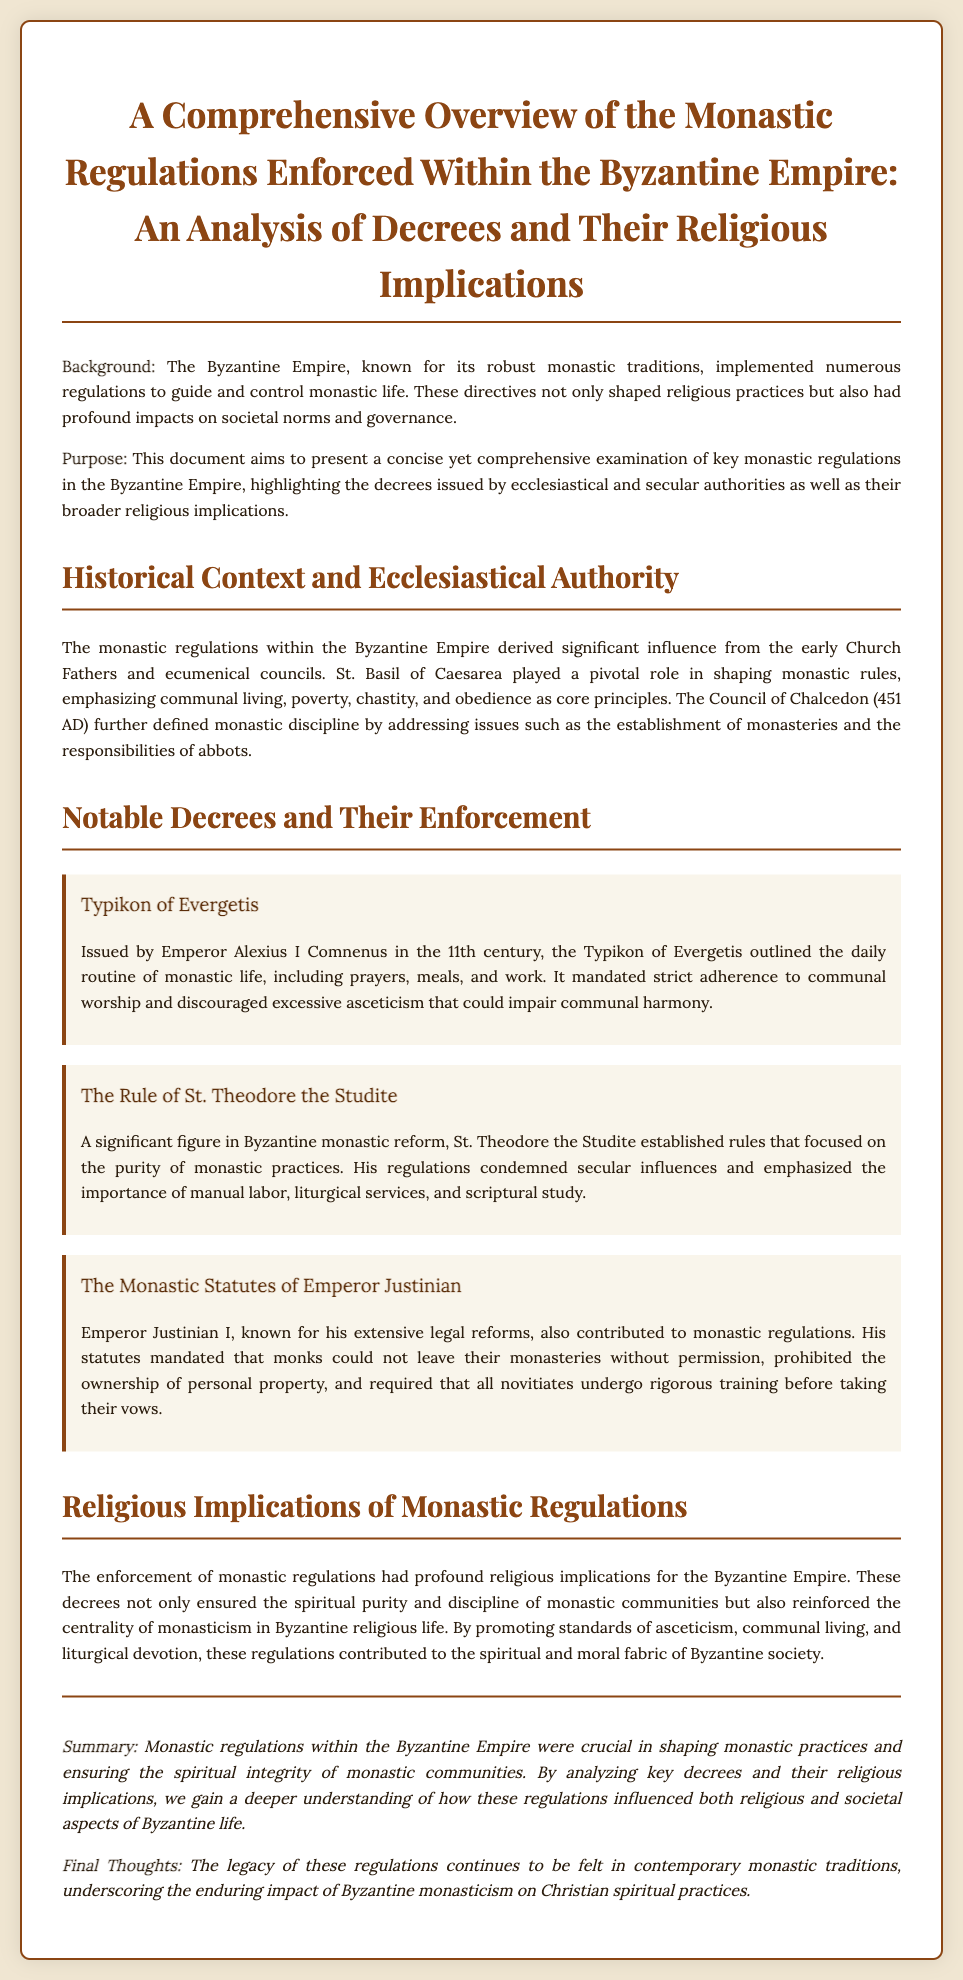What was the role of St. Basil in monastic regulations? St. Basil of Caesarea played a pivotal role in shaping monastic rules, emphasizing communal living, poverty, chastity, and obedience as core principles.
Answer: Pivotal role Who issued the Typikon of Evergetis? The Typikon of Evergetis was issued by Emperor Alexius I Comnenus in the 11th century.
Answer: Emperor Alexius I Comnenus What significant contributions did Emperor Justinian make regarding monastic life? Emperor Justinian I's statutes mandated that monks could not leave their monasteries without permission and prohibited the ownership of personal property.
Answer: Mandated restrictions Which principle did St. Theodore the Studite emphasize? St. Theodore the Studite emphasized the importance of manual labor, liturgical services, and scriptural study.
Answer: Manual labor What was the purpose of this document? This document aims to present a concise yet comprehensive examination of key monastic regulations in the Byzantine Empire.
Answer: Examination of regulations What does the conclusion suggest about the legacy of these regulations? The conclusion states that the legacy of these regulations continues to be felt in contemporary monastic traditions.
Answer: Enduring impact How did monastic regulations affect Byzantine society? The enforcement of monastic regulations contributed to the spiritual and moral fabric of Byzantine society.
Answer: Spiritual and moral fabric What was the Council of Chalcedon? The Council of Chalcedon (451 AD) further defined monastic discipline by addressing issues such as the establishment of monasteries.
Answer: 451 AD 